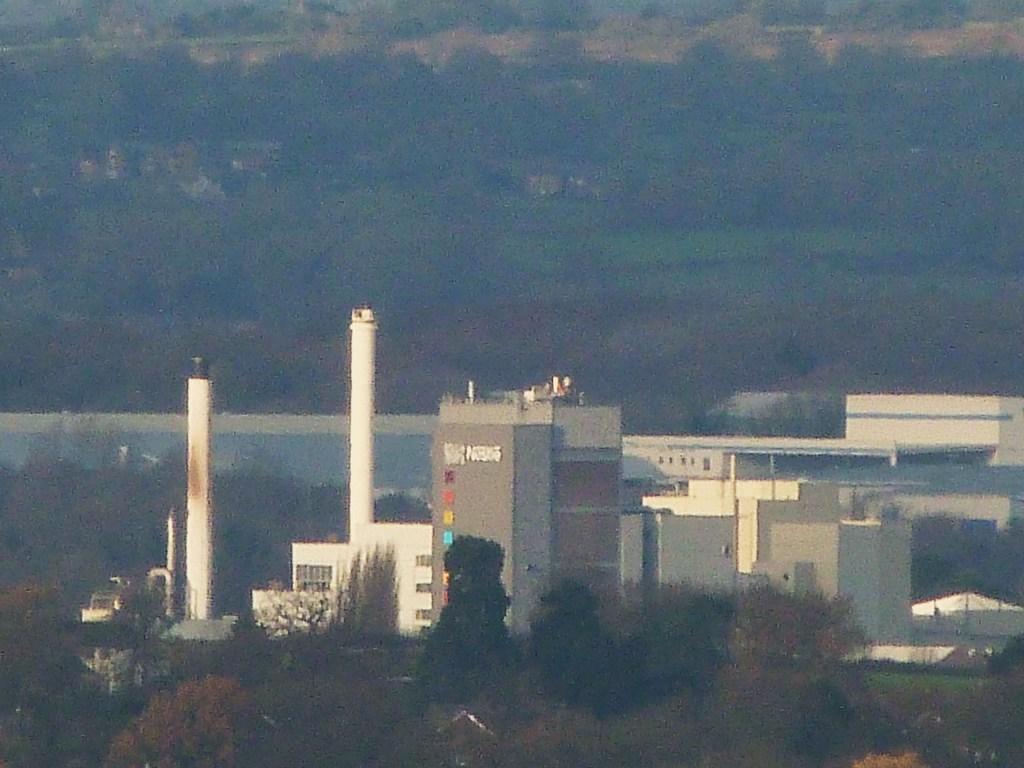Could you give a brief overview of what you see in this image? In this image we can see buildings and trees. 